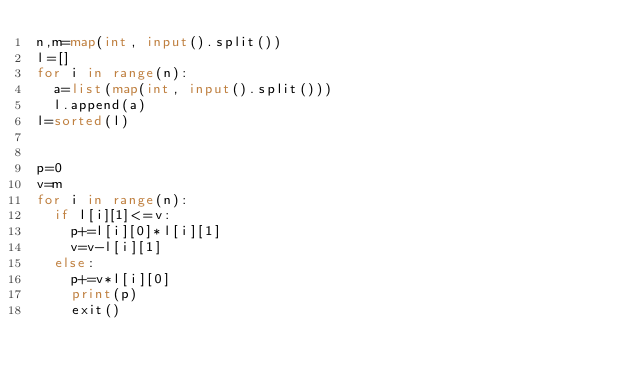Convert code to text. <code><loc_0><loc_0><loc_500><loc_500><_Python_>n,m=map(int, input().split())
l=[]
for i in range(n):
	a=list(map(int, input().split()))
	l.append(a)
l=sorted(l)


p=0
v=m
for i in range(n):
	if l[i][1]<=v:
		p+=l[i][0]*l[i][1]
		v=v-l[i][1]
	else:
		p+=v*l[i][0]
		print(p)
		exit()
	</code> 